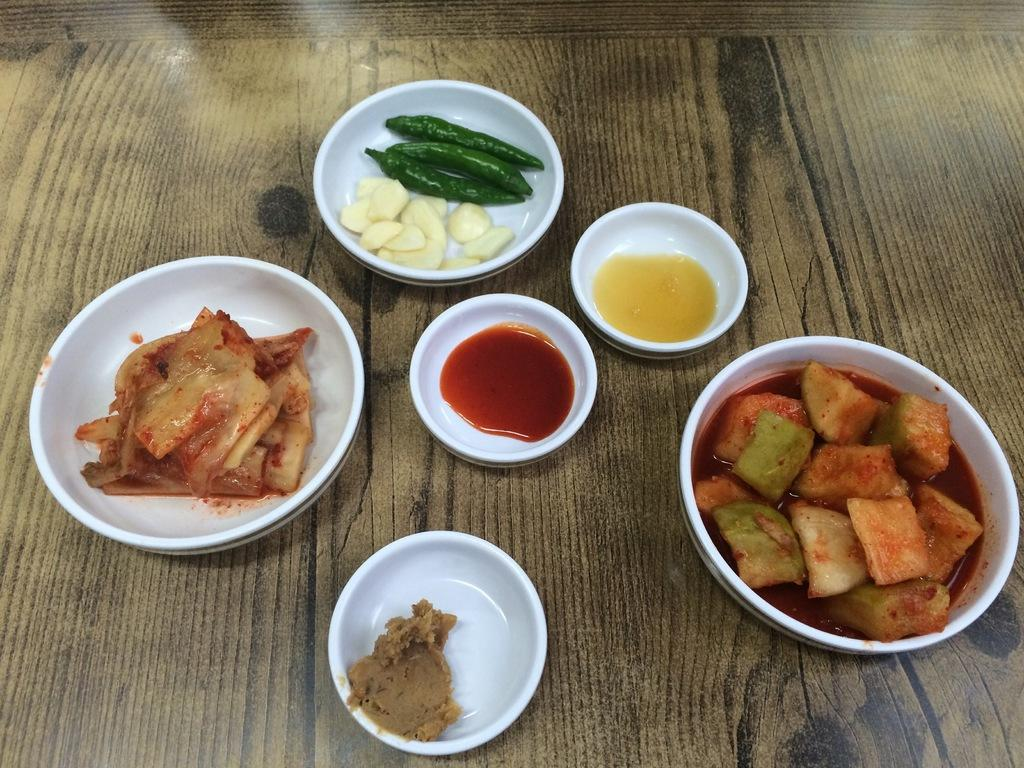What is the main object in the image? There is a bowl in the image. What is inside the bowl? There is food in the image. What type of food can be seen in the bowl? Green chillies are present in the image. On what surface are the objects placed? The objects are placed on a wooden platform. What is the weight of the vessel in the image? There is no vessel present in the image, so it is not possible to determine its weight. 